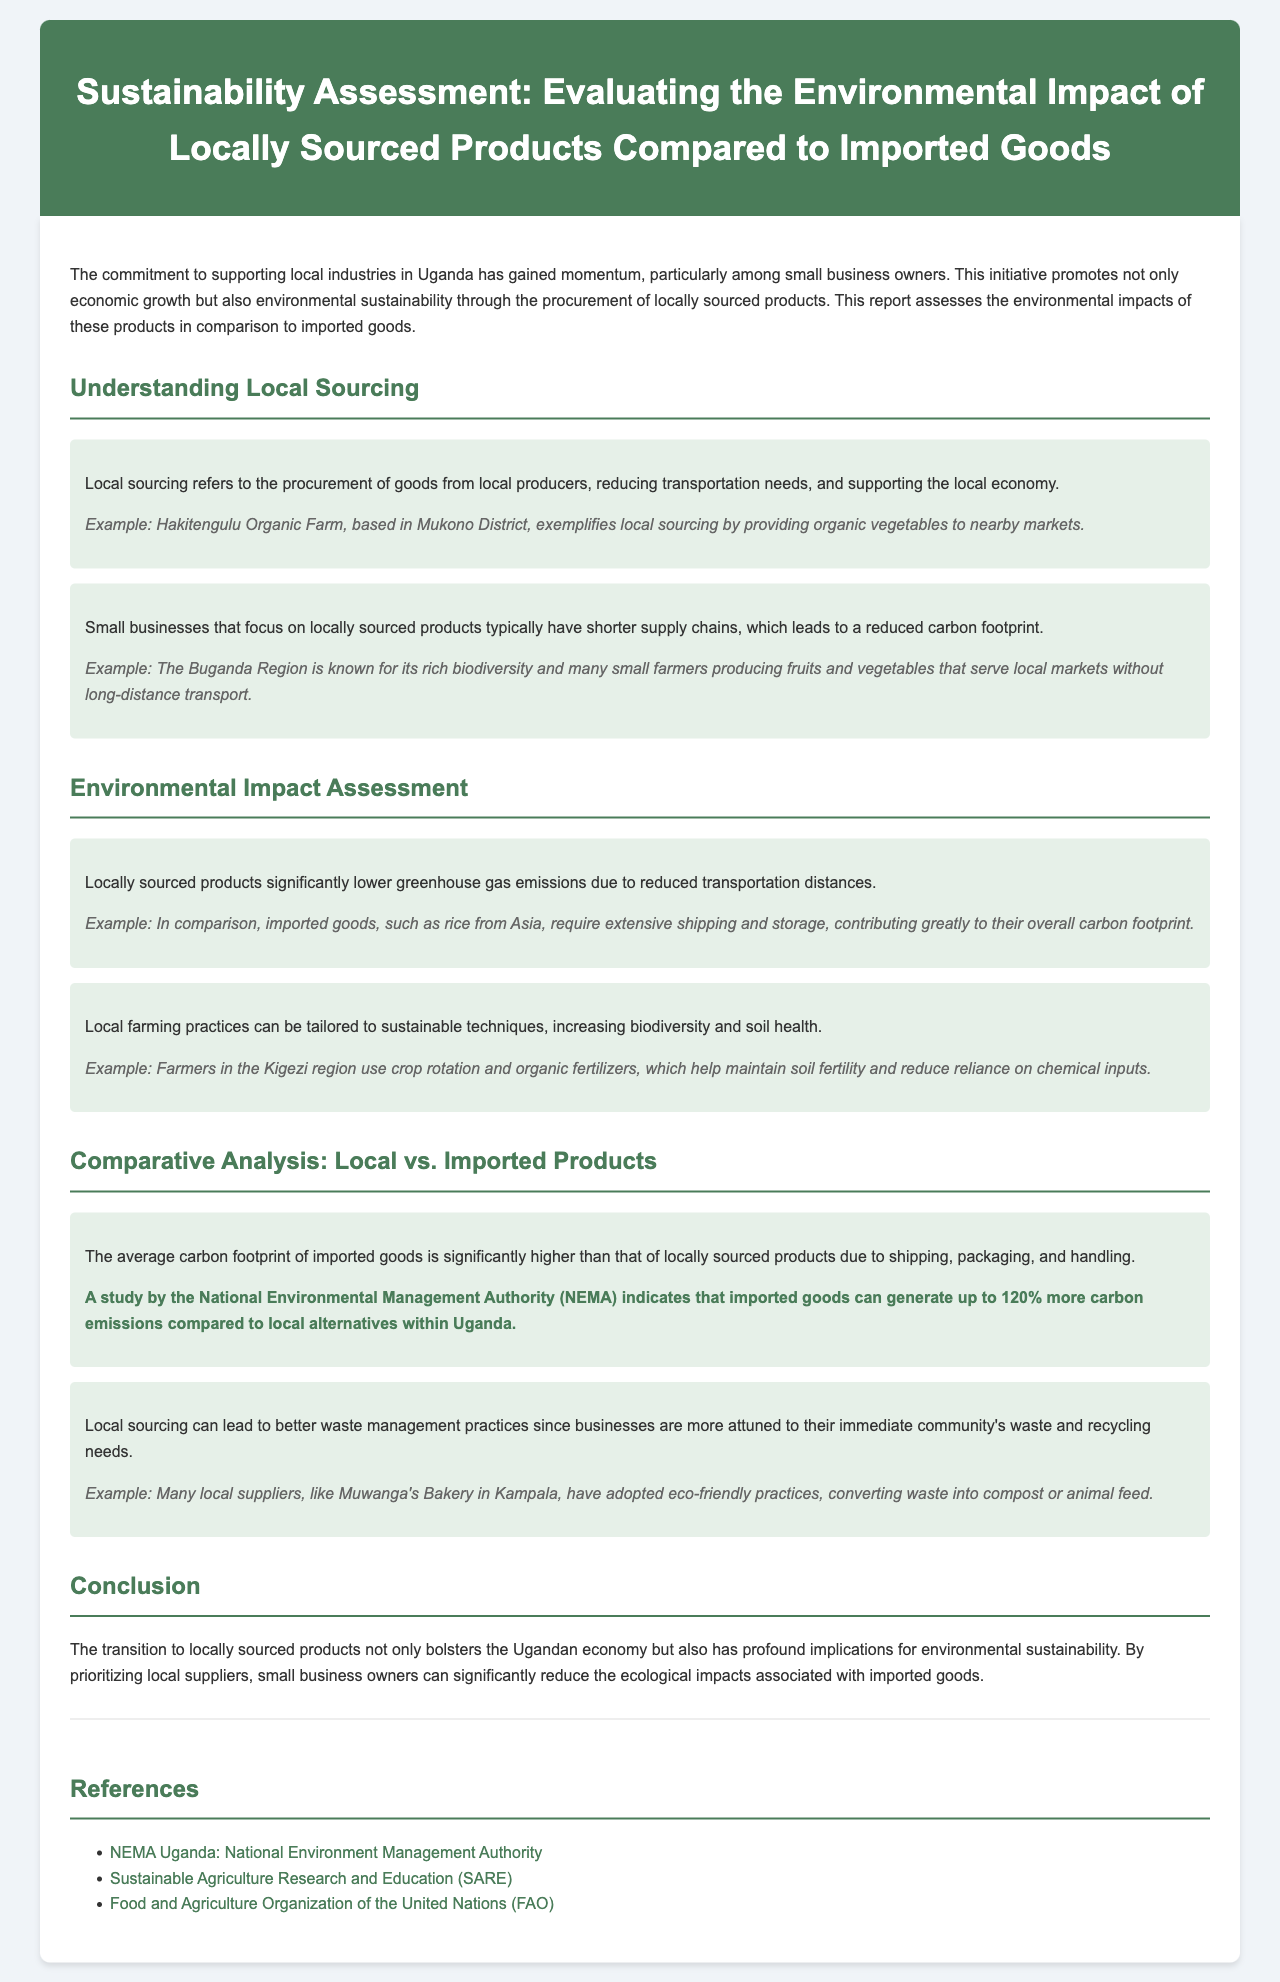What is the title of the report? The title of the report is stated in the header section, highlighting the main focus of the document.
Answer: Sustainability Assessment: Evaluating the Environmental Impact of Locally Sourced Products Compared to Imported Goods What does local sourcing refer to? Local sourcing is described in the document as the procurement of goods from local producers, emphasizing reduced transportation needs.
Answer: Procurement of goods from local producers What example is given for local sourcing? An example is provided in the document that illustrates a specific local farm contributing produce to nearby markets.
Answer: Hakitengulu Organic Farm How much more carbon emissions can imported goods generate? The report uses a specific statistic from a study to quantify the increased carbon emissions associated with imported goods compared to local alternatives.
Answer: Up to 120% Which region is known for its rich biodiversity according to the document? The document identifies a specific area in Uganda that is noted for its diverse ecological offerings beneficial for local production.
Answer: Buganda Region What is one method used by farmers in the Kigezi region to maintain soil health? The document outlines sustainable farming practices utilized in the Kigezi region that enhance soil fertility.
Answer: Crop rotation How do local suppliers contribute to waste management? The report discusses practices employed by local suppliers that reflect their responsiveness to their community's environmental needs, specifically waste management.
Answer: Eco-friendly practices What are the implications of prioritizing local suppliers according to the conclusion? The conclusion summarizes the overarching benefits of supporting local suppliers, which touches on both economic and environmental aspects.
Answer: Economic growth and environmental sustainability 